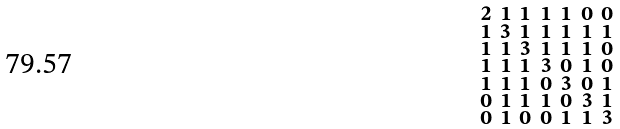<formula> <loc_0><loc_0><loc_500><loc_500>\begin{smallmatrix} 2 & 1 & 1 & 1 & 1 & 0 & 0 \\ 1 & 3 & 1 & 1 & 1 & 1 & 1 \\ 1 & 1 & 3 & 1 & 1 & 1 & 0 \\ 1 & 1 & 1 & 3 & 0 & 1 & 0 \\ 1 & 1 & 1 & 0 & 3 & 0 & 1 \\ 0 & 1 & 1 & 1 & 0 & 3 & 1 \\ 0 & 1 & 0 & 0 & 1 & 1 & 3 \end{smallmatrix}</formula> 